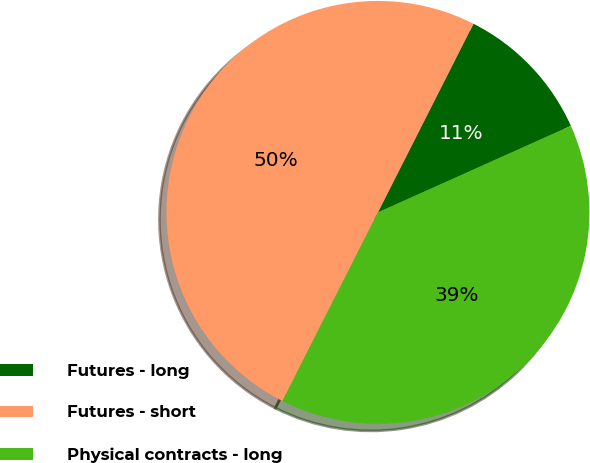Convert chart to OTSL. <chart><loc_0><loc_0><loc_500><loc_500><pie_chart><fcel>Futures - long<fcel>Futures - short<fcel>Physical contracts - long<nl><fcel>10.83%<fcel>50.0%<fcel>39.17%<nl></chart> 